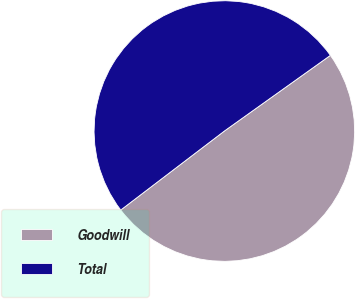<chart> <loc_0><loc_0><loc_500><loc_500><pie_chart><fcel>Goodwill<fcel>Total<nl><fcel>49.5%<fcel>50.5%<nl></chart> 